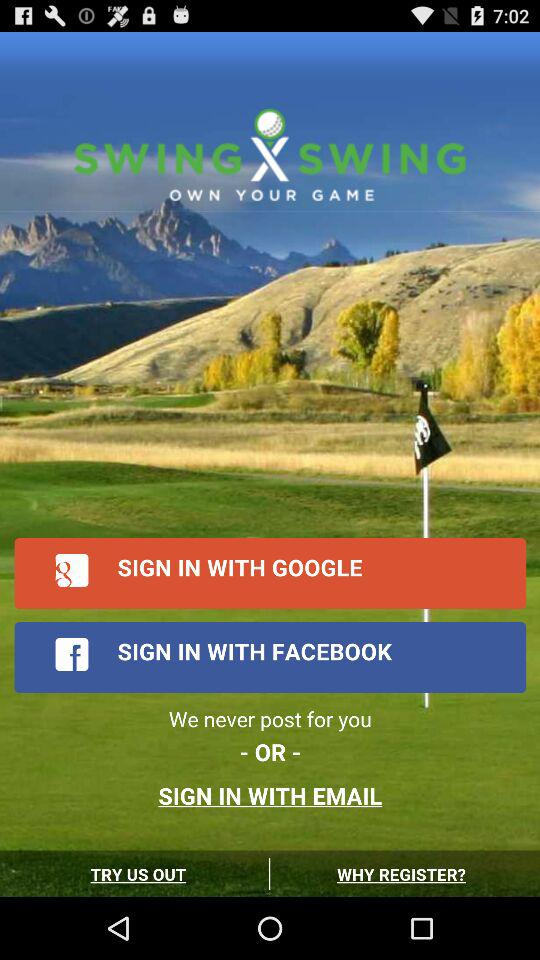How many sign in options are there?
Answer the question using a single word or phrase. 3 